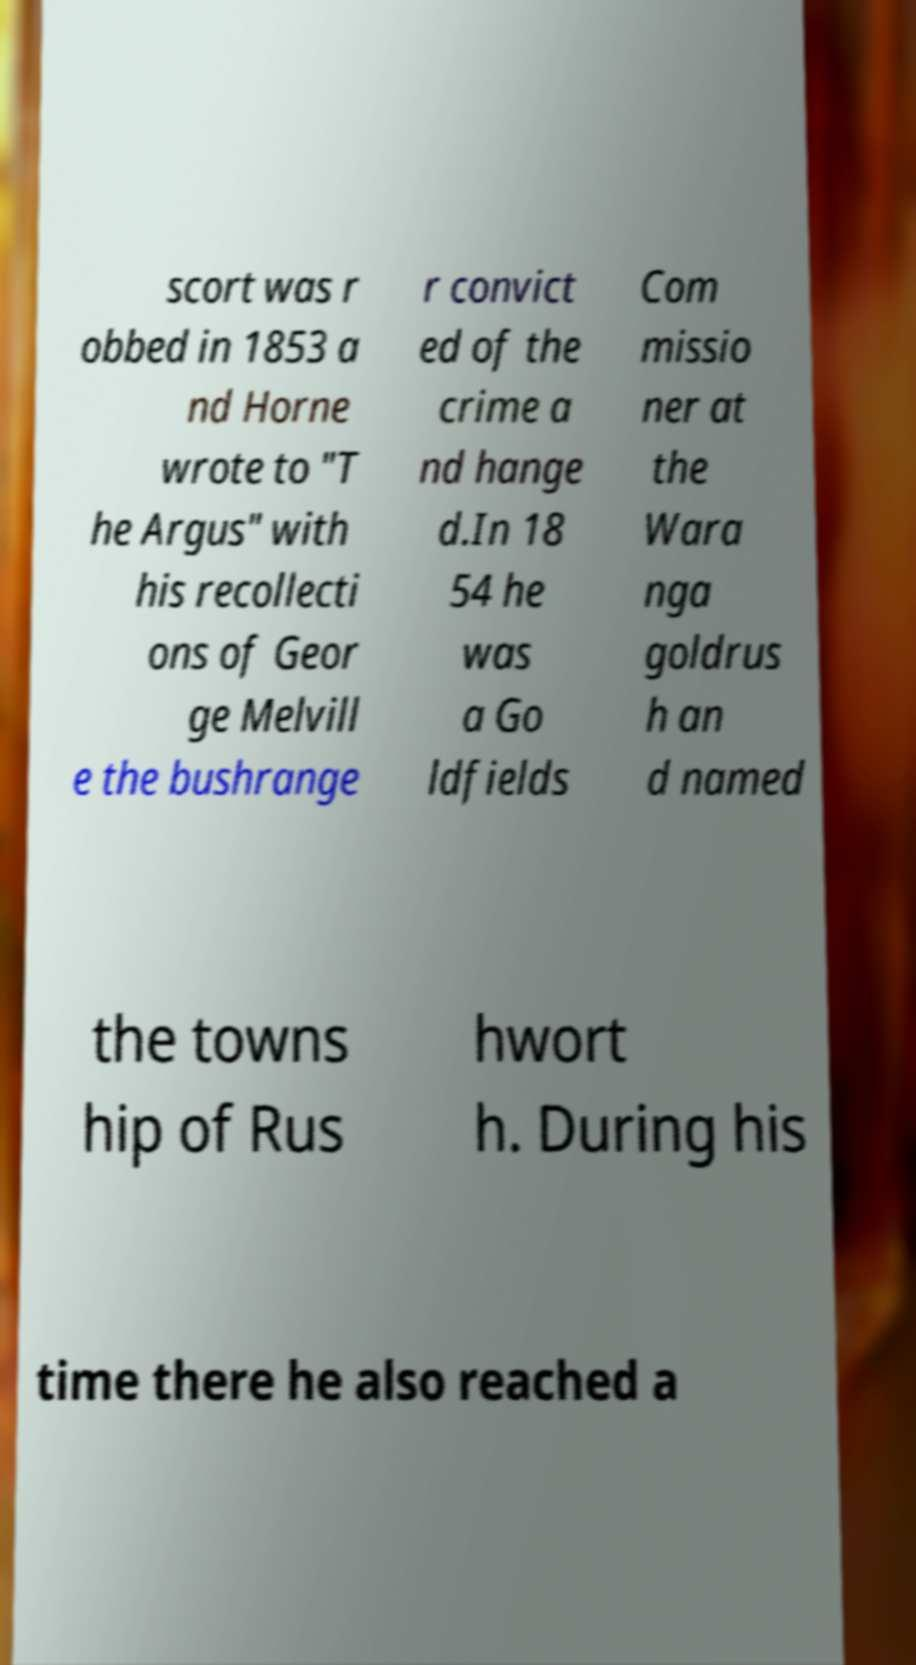Can you accurately transcribe the text from the provided image for me? scort was r obbed in 1853 a nd Horne wrote to "T he Argus" with his recollecti ons of Geor ge Melvill e the bushrange r convict ed of the crime a nd hange d.In 18 54 he was a Go ldfields Com missio ner at the Wara nga goldrus h an d named the towns hip of Rus hwort h. During his time there he also reached a 